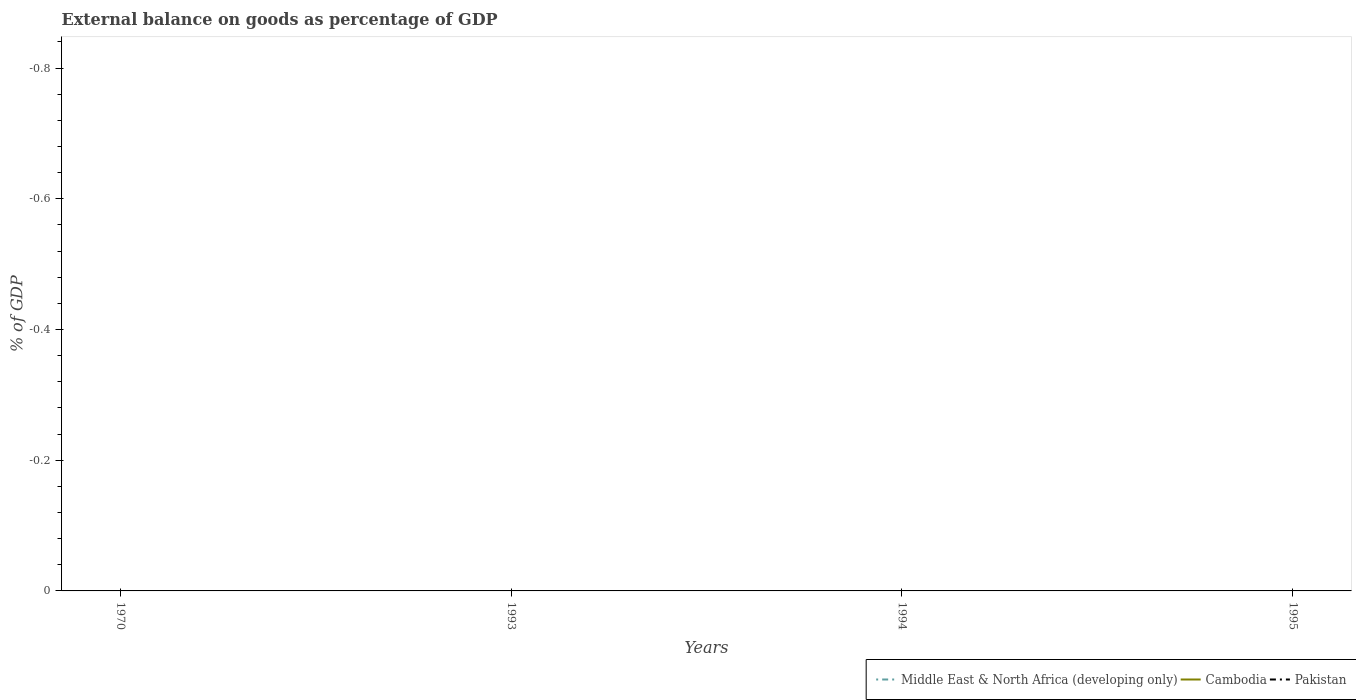How many different coloured lines are there?
Offer a terse response. 0. Does the line corresponding to Pakistan intersect with the line corresponding to Middle East & North Africa (developing only)?
Offer a terse response. Yes. Is the number of lines equal to the number of legend labels?
Your answer should be very brief. No. Across all years, what is the maximum external balance on goods as percentage of GDP in Pakistan?
Provide a succinct answer. 0. What is the difference between the highest and the lowest external balance on goods as percentage of GDP in Middle East & North Africa (developing only)?
Your answer should be compact. 0. Is the external balance on goods as percentage of GDP in Cambodia strictly greater than the external balance on goods as percentage of GDP in Middle East & North Africa (developing only) over the years?
Your answer should be very brief. No. How many years are there in the graph?
Give a very brief answer. 4. What is the difference between two consecutive major ticks on the Y-axis?
Make the answer very short. 0.2. Are the values on the major ticks of Y-axis written in scientific E-notation?
Your response must be concise. No. Where does the legend appear in the graph?
Ensure brevity in your answer.  Bottom right. How are the legend labels stacked?
Provide a short and direct response. Horizontal. What is the title of the graph?
Give a very brief answer. External balance on goods as percentage of GDP. Does "Euro area" appear as one of the legend labels in the graph?
Provide a short and direct response. No. What is the label or title of the X-axis?
Provide a short and direct response. Years. What is the label or title of the Y-axis?
Keep it short and to the point. % of GDP. What is the % of GDP in Middle East & North Africa (developing only) in 1970?
Your answer should be compact. 0. What is the % of GDP of Pakistan in 1970?
Make the answer very short. 0. What is the % of GDP in Cambodia in 1993?
Keep it short and to the point. 0. What is the % of GDP in Pakistan in 1993?
Offer a very short reply. 0. What is the % of GDP of Pakistan in 1994?
Offer a very short reply. 0. What is the % of GDP of Cambodia in 1995?
Your response must be concise. 0. What is the % of GDP in Pakistan in 1995?
Your answer should be very brief. 0. What is the total % of GDP of Middle East & North Africa (developing only) in the graph?
Offer a very short reply. 0. What is the total % of GDP of Cambodia in the graph?
Your answer should be compact. 0. What is the total % of GDP of Pakistan in the graph?
Offer a very short reply. 0. What is the average % of GDP of Middle East & North Africa (developing only) per year?
Your answer should be very brief. 0. 